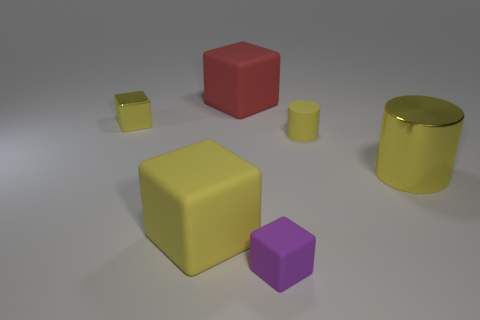What size is the red cube that is the same material as the purple object?
Offer a terse response. Large. What shape is the red matte thing?
Your response must be concise. Cube. Is the material of the large yellow block the same as the tiny yellow object right of the big red matte block?
Offer a terse response. Yes. What number of objects are cyan metal things or rubber objects?
Your response must be concise. 4. Is there a big brown ball?
Your answer should be compact. No. There is a small yellow thing in front of the tiny yellow object behind the small rubber cylinder; what shape is it?
Your response must be concise. Cylinder. How many things are either large objects on the right side of the yellow matte cube or yellow metal objects that are behind the matte cylinder?
Offer a terse response. 3. There is a yellow block that is the same size as the matte cylinder; what material is it?
Your answer should be very brief. Metal. The shiny block is what color?
Provide a succinct answer. Yellow. What material is the yellow object that is to the left of the purple rubber object and in front of the tiny yellow cylinder?
Provide a short and direct response. Rubber. 